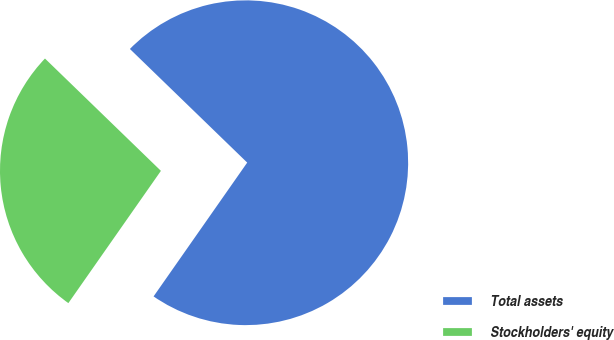Convert chart. <chart><loc_0><loc_0><loc_500><loc_500><pie_chart><fcel>Total assets<fcel>Stockholders' equity<nl><fcel>72.47%<fcel>27.53%<nl></chart> 